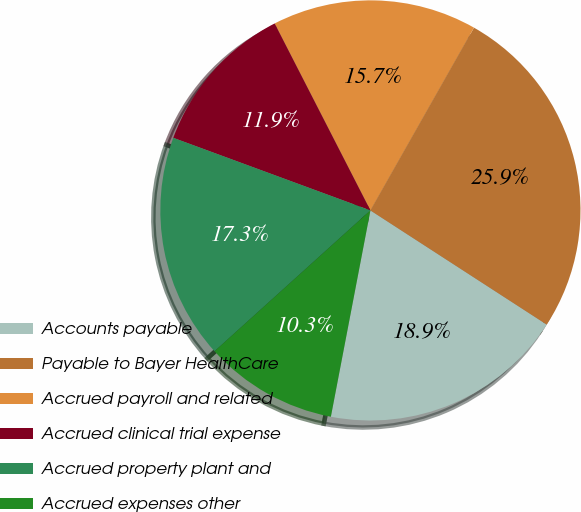Convert chart. <chart><loc_0><loc_0><loc_500><loc_500><pie_chart><fcel>Accounts payable<fcel>Payable to Bayer HealthCare<fcel>Accrued payroll and related<fcel>Accrued clinical trial expense<fcel>Accrued property plant and<fcel>Accrued expenses other<nl><fcel>18.87%<fcel>25.94%<fcel>15.74%<fcel>11.85%<fcel>17.31%<fcel>10.29%<nl></chart> 